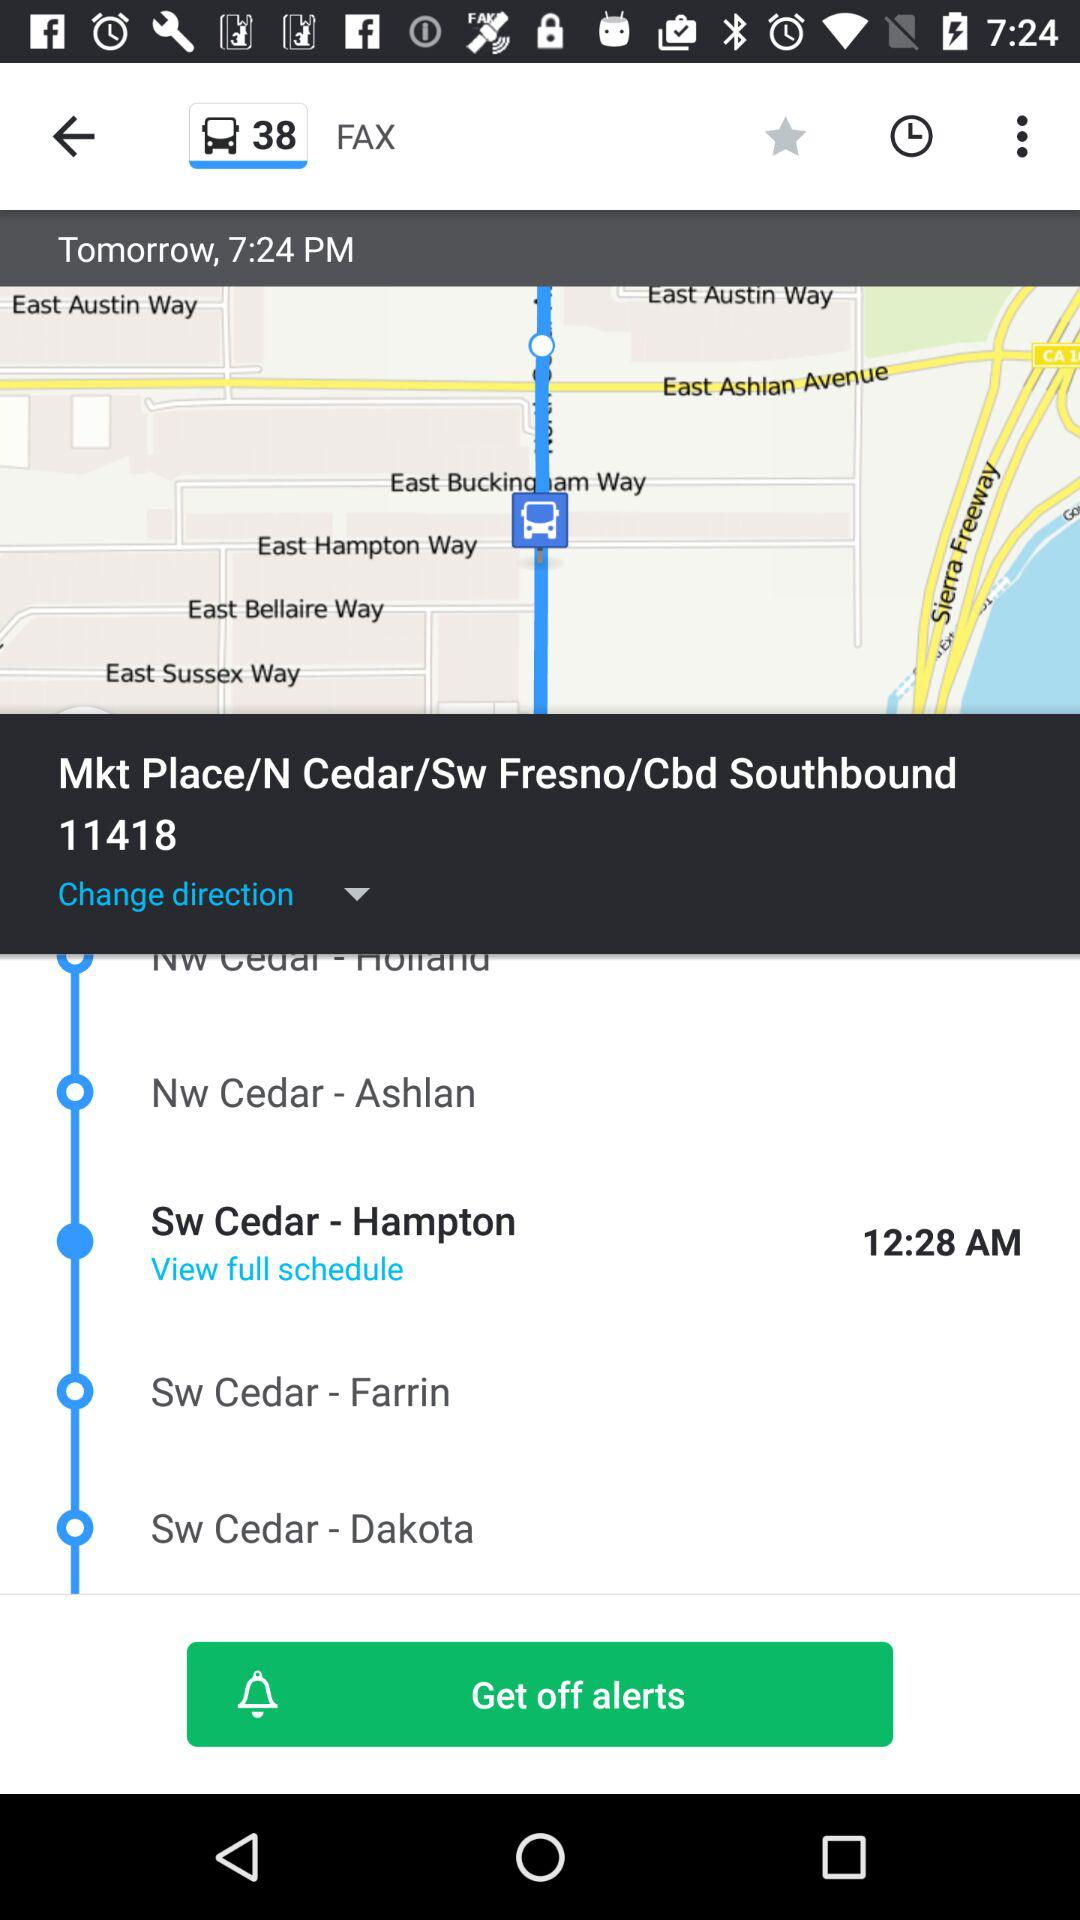What is the train number? The train number is 38. 